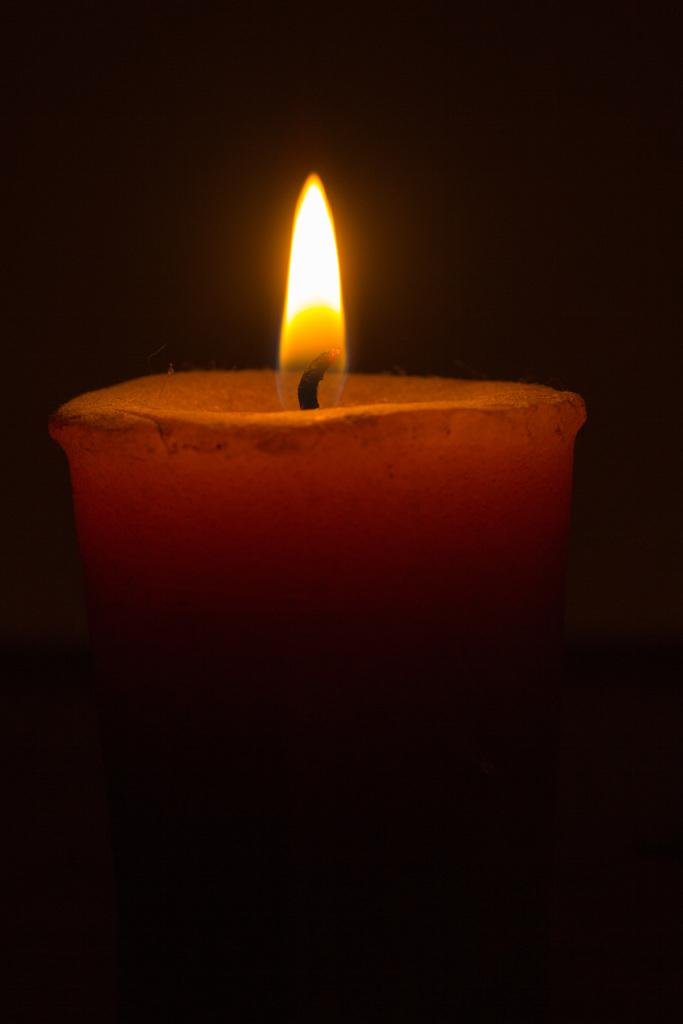What object can be seen in the image that might provide light? There is a candle in the image. How would you describe the lighting conditions in the image? The image is in the dark. Can you see any signs of an earthquake happening in the image? There is no indication of an earthquake in the image. Are there any snails visible on the candle in the image? There are no snails present on the candle in the image. 